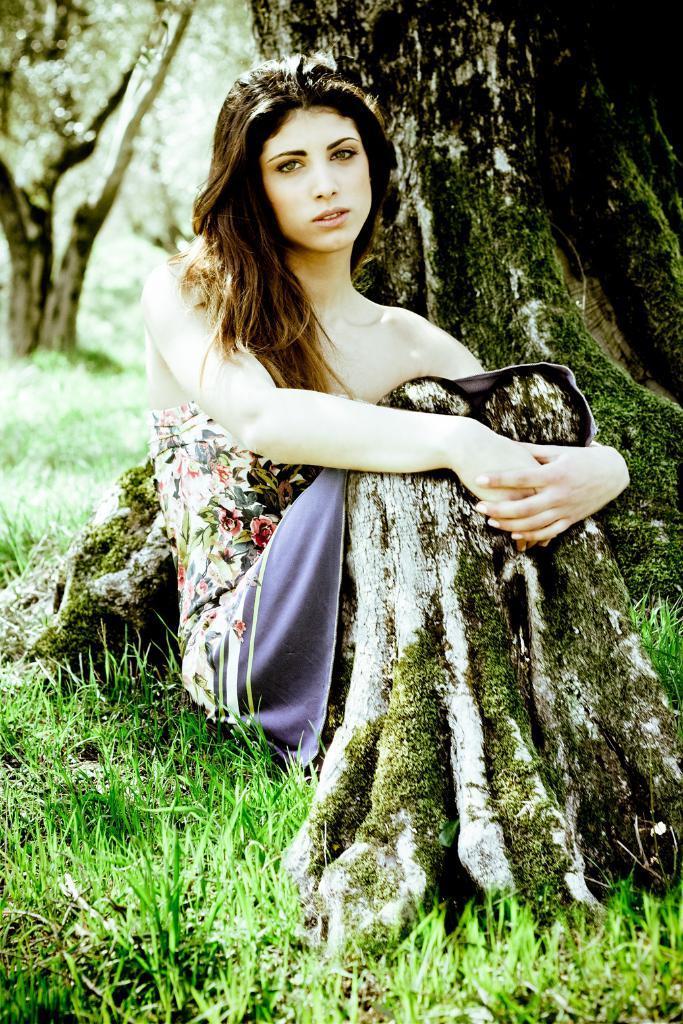Can you describe this image briefly? In this picture I can see a woman sitting on the grass, behind there are some trees. 